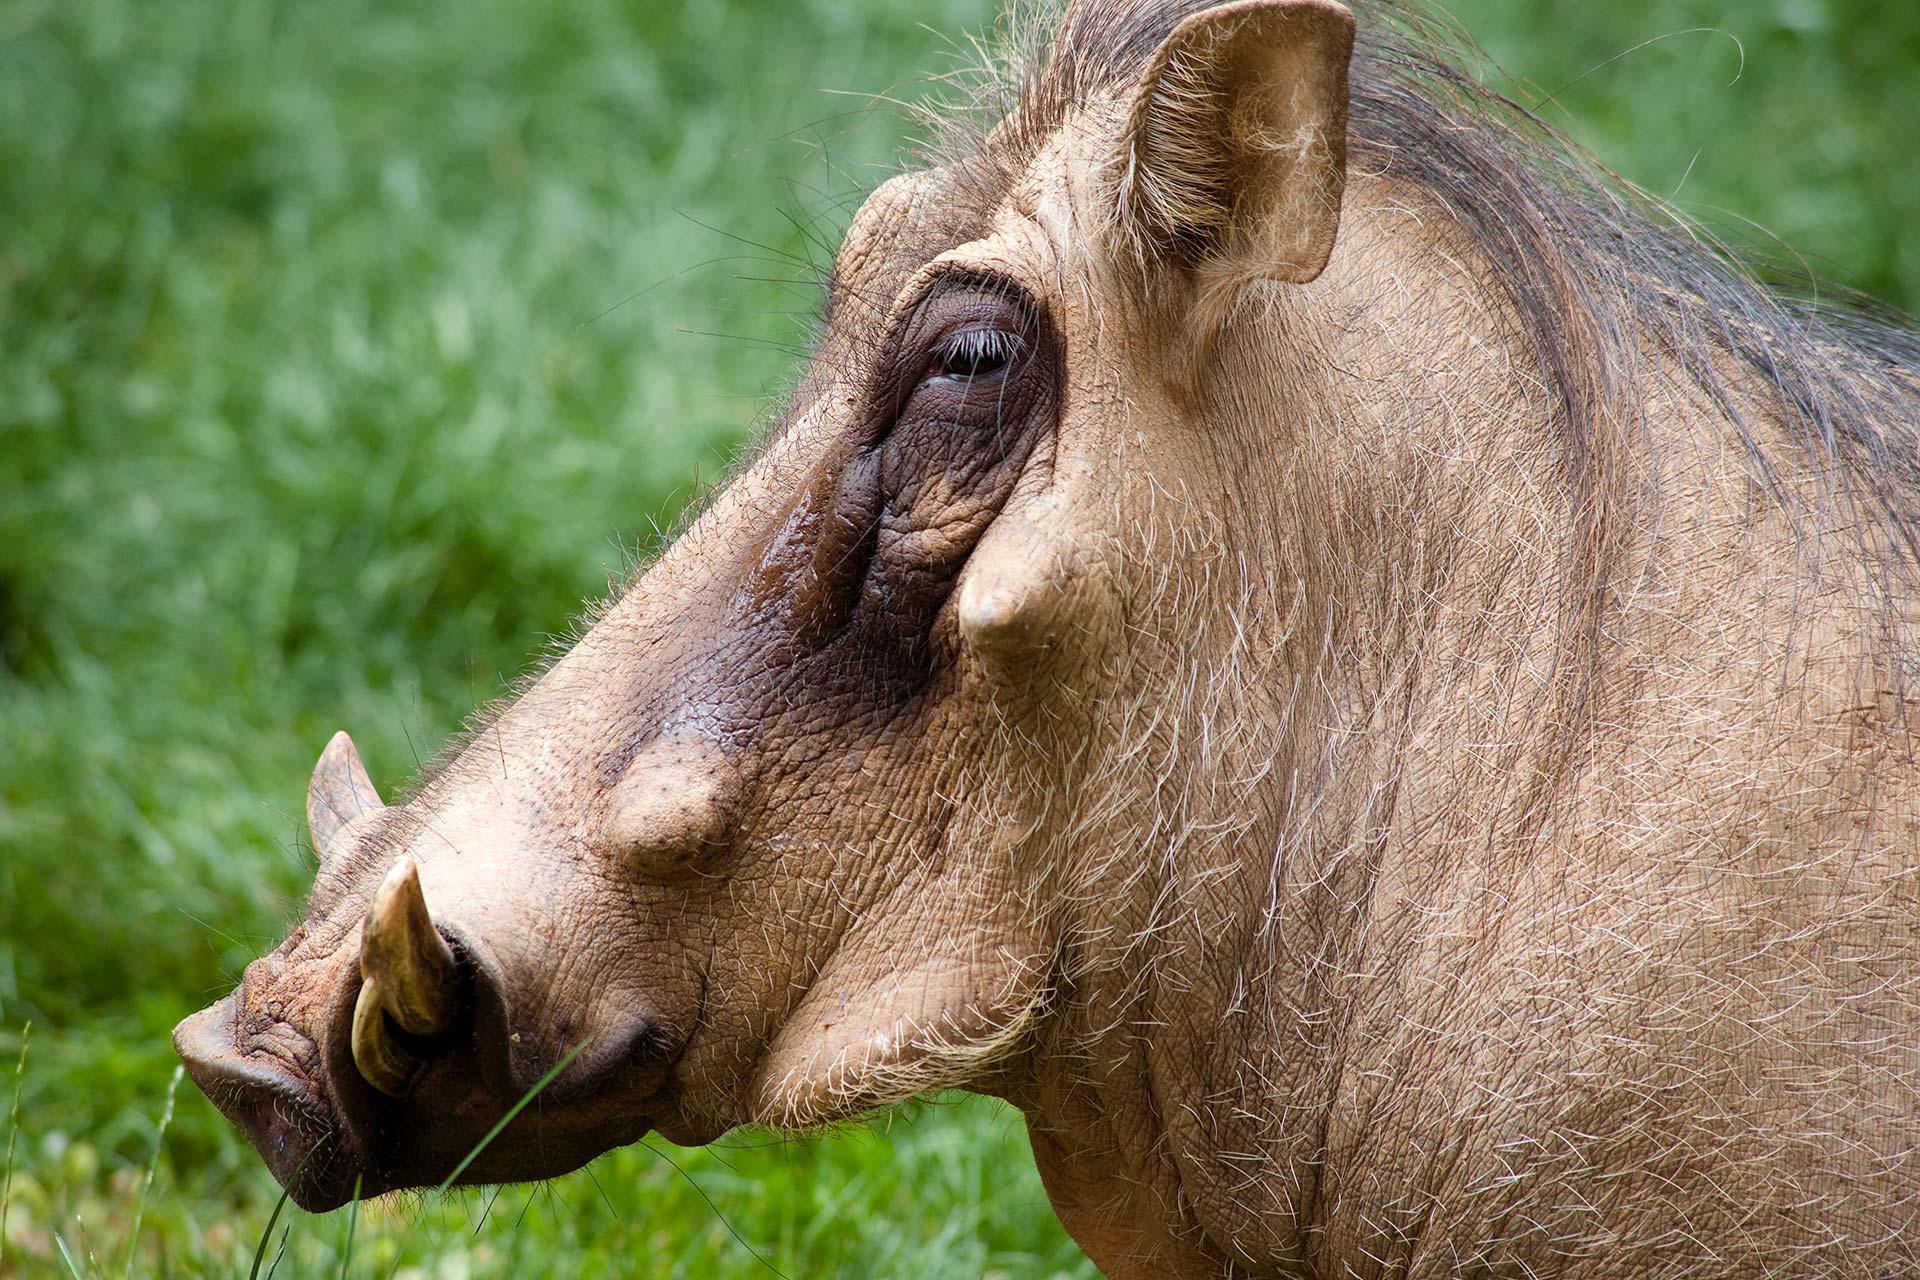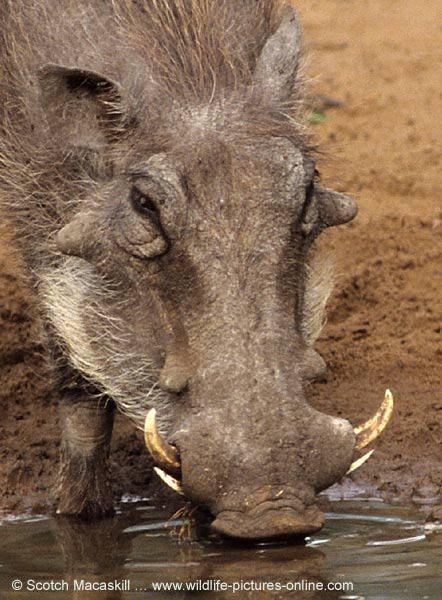The first image is the image on the left, the second image is the image on the right. For the images shown, is this caption "There are two hogs, both facing the same direction." true? Answer yes or no. No. The first image is the image on the left, the second image is the image on the right. Examine the images to the left and right. Is the description "Each image contains one warthog, and each warthog is standing with its body facing the same direction." accurate? Answer yes or no. No. 